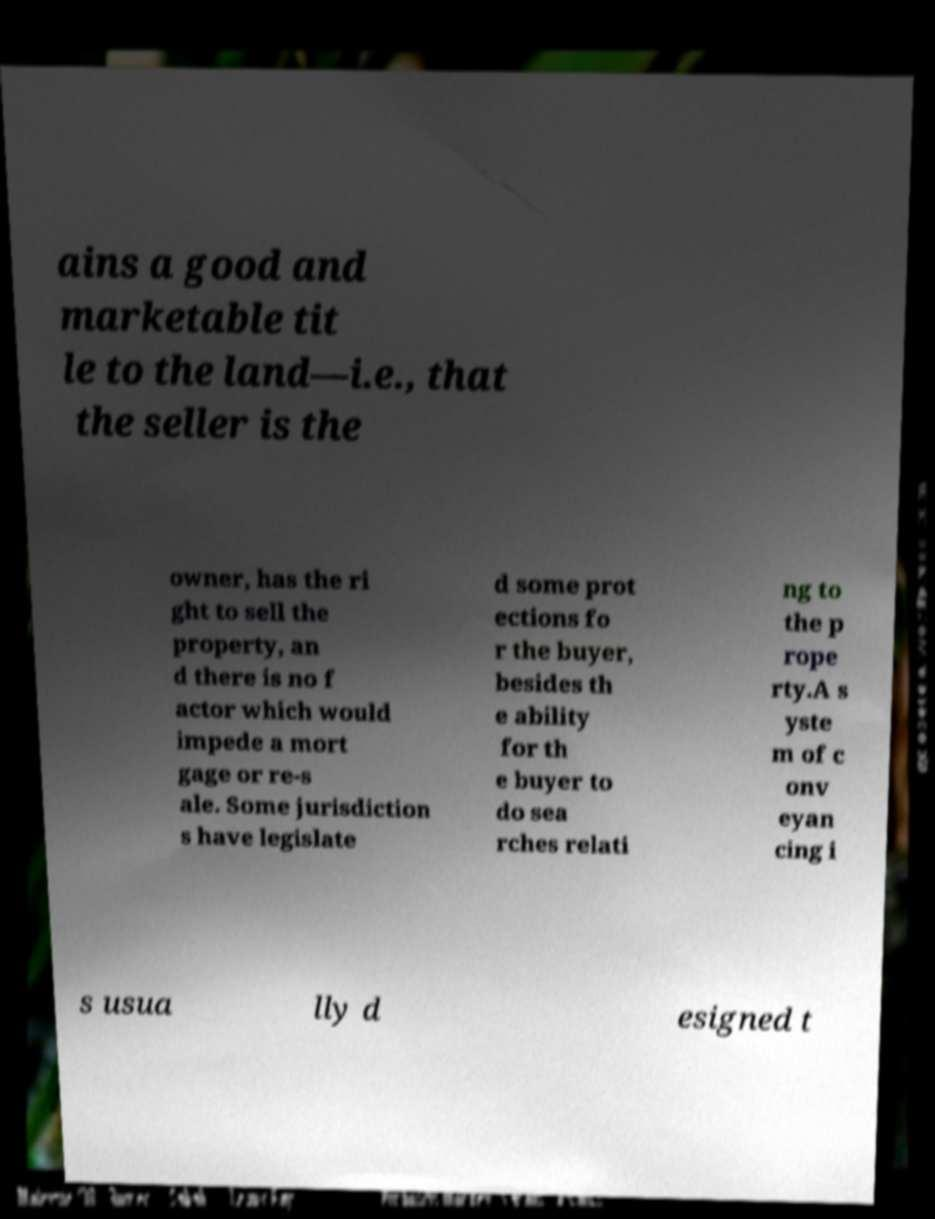Could you extract and type out the text from this image? ains a good and marketable tit le to the land—i.e., that the seller is the owner, has the ri ght to sell the property, an d there is no f actor which would impede a mort gage or re-s ale. Some jurisdiction s have legislate d some prot ections fo r the buyer, besides th e ability for th e buyer to do sea rches relati ng to the p rope rty.A s yste m of c onv eyan cing i s usua lly d esigned t 